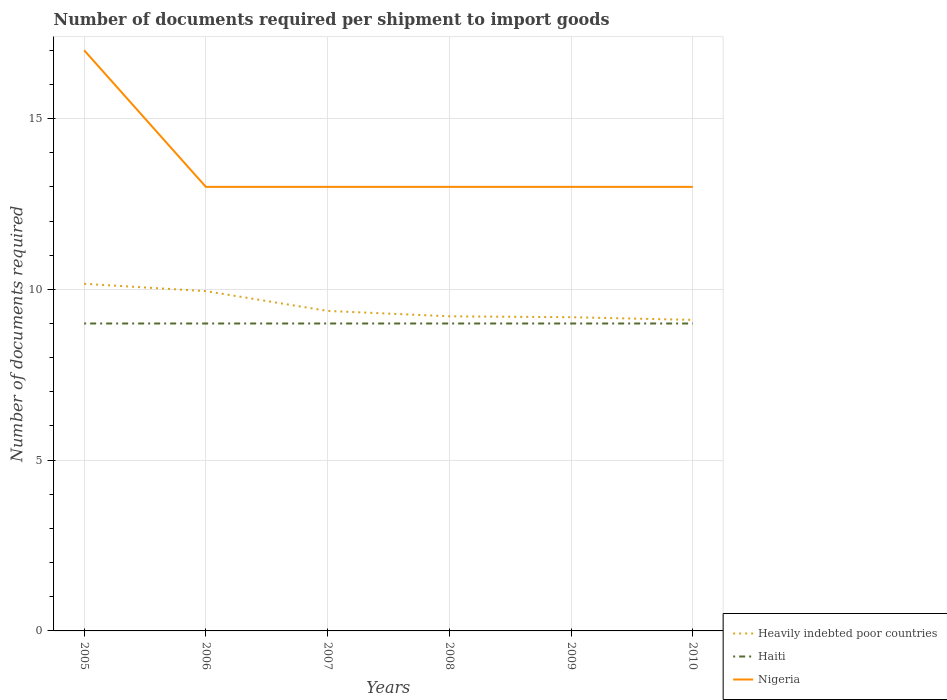Across all years, what is the maximum number of documents required per shipment to import goods in Haiti?
Keep it short and to the point. 9. In which year was the number of documents required per shipment to import goods in Nigeria maximum?
Your response must be concise. 2006. What is the total number of documents required per shipment to import goods in Heavily indebted poor countries in the graph?
Provide a succinct answer. 0.18. What is the difference between the highest and the second highest number of documents required per shipment to import goods in Nigeria?
Offer a terse response. 4. Is the number of documents required per shipment to import goods in Haiti strictly greater than the number of documents required per shipment to import goods in Nigeria over the years?
Keep it short and to the point. Yes. What is the difference between two consecutive major ticks on the Y-axis?
Make the answer very short. 5. How many legend labels are there?
Ensure brevity in your answer.  3. What is the title of the graph?
Your answer should be compact. Number of documents required per shipment to import goods. Does "Monaco" appear as one of the legend labels in the graph?
Give a very brief answer. No. What is the label or title of the Y-axis?
Offer a very short reply. Number of documents required. What is the Number of documents required in Heavily indebted poor countries in 2005?
Make the answer very short. 10.16. What is the Number of documents required in Haiti in 2005?
Make the answer very short. 9. What is the Number of documents required in Heavily indebted poor countries in 2006?
Ensure brevity in your answer.  9.95. What is the Number of documents required of Haiti in 2006?
Provide a short and direct response. 9. What is the Number of documents required in Heavily indebted poor countries in 2007?
Provide a short and direct response. 9.37. What is the Number of documents required of Haiti in 2007?
Your answer should be compact. 9. What is the Number of documents required of Nigeria in 2007?
Your answer should be compact. 13. What is the Number of documents required in Heavily indebted poor countries in 2008?
Your answer should be very brief. 9.21. What is the Number of documents required of Heavily indebted poor countries in 2009?
Provide a short and direct response. 9.18. What is the Number of documents required in Nigeria in 2009?
Provide a short and direct response. 13. What is the Number of documents required of Heavily indebted poor countries in 2010?
Give a very brief answer. 9.11. What is the Number of documents required in Haiti in 2010?
Offer a terse response. 9. What is the Number of documents required in Nigeria in 2010?
Provide a succinct answer. 13. Across all years, what is the maximum Number of documents required in Heavily indebted poor countries?
Offer a very short reply. 10.16. Across all years, what is the minimum Number of documents required in Heavily indebted poor countries?
Your answer should be compact. 9.11. Across all years, what is the minimum Number of documents required of Haiti?
Make the answer very short. 9. Across all years, what is the minimum Number of documents required of Nigeria?
Your answer should be very brief. 13. What is the total Number of documents required of Heavily indebted poor countries in the graph?
Your answer should be very brief. 56.98. What is the total Number of documents required in Nigeria in the graph?
Ensure brevity in your answer.  82. What is the difference between the Number of documents required of Heavily indebted poor countries in 2005 and that in 2006?
Your answer should be very brief. 0.21. What is the difference between the Number of documents required of Nigeria in 2005 and that in 2006?
Provide a succinct answer. 4. What is the difference between the Number of documents required of Heavily indebted poor countries in 2005 and that in 2007?
Make the answer very short. 0.79. What is the difference between the Number of documents required of Haiti in 2005 and that in 2007?
Offer a very short reply. 0. What is the difference between the Number of documents required in Nigeria in 2005 and that in 2007?
Your answer should be very brief. 4. What is the difference between the Number of documents required in Heavily indebted poor countries in 2005 and that in 2008?
Your response must be concise. 0.95. What is the difference between the Number of documents required in Nigeria in 2005 and that in 2008?
Provide a succinct answer. 4. What is the difference between the Number of documents required in Nigeria in 2005 and that in 2009?
Give a very brief answer. 4. What is the difference between the Number of documents required in Heavily indebted poor countries in 2005 and that in 2010?
Make the answer very short. 1.06. What is the difference between the Number of documents required of Haiti in 2005 and that in 2010?
Your response must be concise. 0. What is the difference between the Number of documents required of Heavily indebted poor countries in 2006 and that in 2007?
Offer a terse response. 0.58. What is the difference between the Number of documents required in Heavily indebted poor countries in 2006 and that in 2008?
Keep it short and to the point. 0.74. What is the difference between the Number of documents required of Haiti in 2006 and that in 2008?
Offer a terse response. 0. What is the difference between the Number of documents required in Heavily indebted poor countries in 2006 and that in 2009?
Your answer should be very brief. 0.76. What is the difference between the Number of documents required in Haiti in 2006 and that in 2009?
Provide a succinct answer. 0. What is the difference between the Number of documents required in Heavily indebted poor countries in 2006 and that in 2010?
Give a very brief answer. 0.84. What is the difference between the Number of documents required of Haiti in 2006 and that in 2010?
Offer a very short reply. 0. What is the difference between the Number of documents required of Heavily indebted poor countries in 2007 and that in 2008?
Make the answer very short. 0.16. What is the difference between the Number of documents required of Haiti in 2007 and that in 2008?
Keep it short and to the point. 0. What is the difference between the Number of documents required in Nigeria in 2007 and that in 2008?
Offer a terse response. 0. What is the difference between the Number of documents required in Heavily indebted poor countries in 2007 and that in 2009?
Give a very brief answer. 0.18. What is the difference between the Number of documents required of Haiti in 2007 and that in 2009?
Offer a terse response. 0. What is the difference between the Number of documents required in Nigeria in 2007 and that in 2009?
Offer a very short reply. 0. What is the difference between the Number of documents required of Heavily indebted poor countries in 2007 and that in 2010?
Your answer should be compact. 0.26. What is the difference between the Number of documents required in Nigeria in 2007 and that in 2010?
Provide a short and direct response. 0. What is the difference between the Number of documents required in Heavily indebted poor countries in 2008 and that in 2009?
Make the answer very short. 0.03. What is the difference between the Number of documents required of Haiti in 2008 and that in 2009?
Make the answer very short. 0. What is the difference between the Number of documents required in Nigeria in 2008 and that in 2009?
Your answer should be very brief. 0. What is the difference between the Number of documents required in Heavily indebted poor countries in 2008 and that in 2010?
Make the answer very short. 0.11. What is the difference between the Number of documents required in Heavily indebted poor countries in 2009 and that in 2010?
Offer a very short reply. 0.08. What is the difference between the Number of documents required of Heavily indebted poor countries in 2005 and the Number of documents required of Haiti in 2006?
Provide a succinct answer. 1.16. What is the difference between the Number of documents required in Heavily indebted poor countries in 2005 and the Number of documents required in Nigeria in 2006?
Your answer should be compact. -2.84. What is the difference between the Number of documents required in Heavily indebted poor countries in 2005 and the Number of documents required in Haiti in 2007?
Provide a short and direct response. 1.16. What is the difference between the Number of documents required of Heavily indebted poor countries in 2005 and the Number of documents required of Nigeria in 2007?
Make the answer very short. -2.84. What is the difference between the Number of documents required of Heavily indebted poor countries in 2005 and the Number of documents required of Haiti in 2008?
Provide a short and direct response. 1.16. What is the difference between the Number of documents required of Heavily indebted poor countries in 2005 and the Number of documents required of Nigeria in 2008?
Your answer should be very brief. -2.84. What is the difference between the Number of documents required in Heavily indebted poor countries in 2005 and the Number of documents required in Haiti in 2009?
Your response must be concise. 1.16. What is the difference between the Number of documents required in Heavily indebted poor countries in 2005 and the Number of documents required in Nigeria in 2009?
Keep it short and to the point. -2.84. What is the difference between the Number of documents required of Haiti in 2005 and the Number of documents required of Nigeria in 2009?
Provide a short and direct response. -4. What is the difference between the Number of documents required of Heavily indebted poor countries in 2005 and the Number of documents required of Haiti in 2010?
Give a very brief answer. 1.16. What is the difference between the Number of documents required of Heavily indebted poor countries in 2005 and the Number of documents required of Nigeria in 2010?
Offer a very short reply. -2.84. What is the difference between the Number of documents required in Haiti in 2005 and the Number of documents required in Nigeria in 2010?
Offer a terse response. -4. What is the difference between the Number of documents required in Heavily indebted poor countries in 2006 and the Number of documents required in Nigeria in 2007?
Your answer should be compact. -3.05. What is the difference between the Number of documents required in Haiti in 2006 and the Number of documents required in Nigeria in 2007?
Provide a short and direct response. -4. What is the difference between the Number of documents required of Heavily indebted poor countries in 2006 and the Number of documents required of Haiti in 2008?
Your answer should be very brief. 0.95. What is the difference between the Number of documents required of Heavily indebted poor countries in 2006 and the Number of documents required of Nigeria in 2008?
Your response must be concise. -3.05. What is the difference between the Number of documents required in Haiti in 2006 and the Number of documents required in Nigeria in 2008?
Offer a very short reply. -4. What is the difference between the Number of documents required of Heavily indebted poor countries in 2006 and the Number of documents required of Nigeria in 2009?
Your answer should be very brief. -3.05. What is the difference between the Number of documents required in Haiti in 2006 and the Number of documents required in Nigeria in 2009?
Offer a terse response. -4. What is the difference between the Number of documents required of Heavily indebted poor countries in 2006 and the Number of documents required of Nigeria in 2010?
Your response must be concise. -3.05. What is the difference between the Number of documents required of Haiti in 2006 and the Number of documents required of Nigeria in 2010?
Provide a short and direct response. -4. What is the difference between the Number of documents required in Heavily indebted poor countries in 2007 and the Number of documents required in Haiti in 2008?
Provide a succinct answer. 0.37. What is the difference between the Number of documents required in Heavily indebted poor countries in 2007 and the Number of documents required in Nigeria in 2008?
Your answer should be compact. -3.63. What is the difference between the Number of documents required in Heavily indebted poor countries in 2007 and the Number of documents required in Haiti in 2009?
Offer a very short reply. 0.37. What is the difference between the Number of documents required in Heavily indebted poor countries in 2007 and the Number of documents required in Nigeria in 2009?
Make the answer very short. -3.63. What is the difference between the Number of documents required in Heavily indebted poor countries in 2007 and the Number of documents required in Haiti in 2010?
Offer a terse response. 0.37. What is the difference between the Number of documents required of Heavily indebted poor countries in 2007 and the Number of documents required of Nigeria in 2010?
Make the answer very short. -3.63. What is the difference between the Number of documents required in Haiti in 2007 and the Number of documents required in Nigeria in 2010?
Your answer should be compact. -4. What is the difference between the Number of documents required in Heavily indebted poor countries in 2008 and the Number of documents required in Haiti in 2009?
Provide a succinct answer. 0.21. What is the difference between the Number of documents required in Heavily indebted poor countries in 2008 and the Number of documents required in Nigeria in 2009?
Your answer should be compact. -3.79. What is the difference between the Number of documents required in Haiti in 2008 and the Number of documents required in Nigeria in 2009?
Offer a very short reply. -4. What is the difference between the Number of documents required in Heavily indebted poor countries in 2008 and the Number of documents required in Haiti in 2010?
Offer a terse response. 0.21. What is the difference between the Number of documents required in Heavily indebted poor countries in 2008 and the Number of documents required in Nigeria in 2010?
Your answer should be compact. -3.79. What is the difference between the Number of documents required in Heavily indebted poor countries in 2009 and the Number of documents required in Haiti in 2010?
Make the answer very short. 0.18. What is the difference between the Number of documents required of Heavily indebted poor countries in 2009 and the Number of documents required of Nigeria in 2010?
Your answer should be compact. -3.82. What is the difference between the Number of documents required in Haiti in 2009 and the Number of documents required in Nigeria in 2010?
Offer a very short reply. -4. What is the average Number of documents required of Heavily indebted poor countries per year?
Your answer should be compact. 9.5. What is the average Number of documents required of Nigeria per year?
Offer a terse response. 13.67. In the year 2005, what is the difference between the Number of documents required in Heavily indebted poor countries and Number of documents required in Haiti?
Your response must be concise. 1.16. In the year 2005, what is the difference between the Number of documents required of Heavily indebted poor countries and Number of documents required of Nigeria?
Make the answer very short. -6.84. In the year 2005, what is the difference between the Number of documents required in Haiti and Number of documents required in Nigeria?
Your answer should be compact. -8. In the year 2006, what is the difference between the Number of documents required of Heavily indebted poor countries and Number of documents required of Nigeria?
Offer a very short reply. -3.05. In the year 2007, what is the difference between the Number of documents required of Heavily indebted poor countries and Number of documents required of Haiti?
Ensure brevity in your answer.  0.37. In the year 2007, what is the difference between the Number of documents required of Heavily indebted poor countries and Number of documents required of Nigeria?
Offer a very short reply. -3.63. In the year 2007, what is the difference between the Number of documents required of Haiti and Number of documents required of Nigeria?
Your answer should be very brief. -4. In the year 2008, what is the difference between the Number of documents required of Heavily indebted poor countries and Number of documents required of Haiti?
Provide a succinct answer. 0.21. In the year 2008, what is the difference between the Number of documents required in Heavily indebted poor countries and Number of documents required in Nigeria?
Provide a succinct answer. -3.79. In the year 2008, what is the difference between the Number of documents required in Haiti and Number of documents required in Nigeria?
Provide a short and direct response. -4. In the year 2009, what is the difference between the Number of documents required in Heavily indebted poor countries and Number of documents required in Haiti?
Make the answer very short. 0.18. In the year 2009, what is the difference between the Number of documents required of Heavily indebted poor countries and Number of documents required of Nigeria?
Ensure brevity in your answer.  -3.82. In the year 2010, what is the difference between the Number of documents required of Heavily indebted poor countries and Number of documents required of Haiti?
Provide a short and direct response. 0.11. In the year 2010, what is the difference between the Number of documents required of Heavily indebted poor countries and Number of documents required of Nigeria?
Provide a succinct answer. -3.89. In the year 2010, what is the difference between the Number of documents required in Haiti and Number of documents required in Nigeria?
Provide a succinct answer. -4. What is the ratio of the Number of documents required in Heavily indebted poor countries in 2005 to that in 2006?
Provide a succinct answer. 1.02. What is the ratio of the Number of documents required in Haiti in 2005 to that in 2006?
Offer a terse response. 1. What is the ratio of the Number of documents required in Nigeria in 2005 to that in 2006?
Offer a very short reply. 1.31. What is the ratio of the Number of documents required in Heavily indebted poor countries in 2005 to that in 2007?
Provide a succinct answer. 1.08. What is the ratio of the Number of documents required of Nigeria in 2005 to that in 2007?
Provide a succinct answer. 1.31. What is the ratio of the Number of documents required in Heavily indebted poor countries in 2005 to that in 2008?
Your response must be concise. 1.1. What is the ratio of the Number of documents required in Nigeria in 2005 to that in 2008?
Offer a very short reply. 1.31. What is the ratio of the Number of documents required in Heavily indebted poor countries in 2005 to that in 2009?
Provide a short and direct response. 1.11. What is the ratio of the Number of documents required in Nigeria in 2005 to that in 2009?
Your answer should be compact. 1.31. What is the ratio of the Number of documents required in Heavily indebted poor countries in 2005 to that in 2010?
Your answer should be very brief. 1.12. What is the ratio of the Number of documents required of Haiti in 2005 to that in 2010?
Ensure brevity in your answer.  1. What is the ratio of the Number of documents required in Nigeria in 2005 to that in 2010?
Ensure brevity in your answer.  1.31. What is the ratio of the Number of documents required of Heavily indebted poor countries in 2006 to that in 2007?
Your answer should be very brief. 1.06. What is the ratio of the Number of documents required of Haiti in 2006 to that in 2007?
Ensure brevity in your answer.  1. What is the ratio of the Number of documents required in Heavily indebted poor countries in 2006 to that in 2008?
Your answer should be compact. 1.08. What is the ratio of the Number of documents required in Haiti in 2006 to that in 2008?
Give a very brief answer. 1. What is the ratio of the Number of documents required in Nigeria in 2006 to that in 2008?
Provide a succinct answer. 1. What is the ratio of the Number of documents required of Heavily indebted poor countries in 2006 to that in 2009?
Make the answer very short. 1.08. What is the ratio of the Number of documents required of Haiti in 2006 to that in 2009?
Give a very brief answer. 1. What is the ratio of the Number of documents required of Heavily indebted poor countries in 2006 to that in 2010?
Your answer should be compact. 1.09. What is the ratio of the Number of documents required in Haiti in 2006 to that in 2010?
Your answer should be very brief. 1. What is the ratio of the Number of documents required in Nigeria in 2006 to that in 2010?
Offer a terse response. 1. What is the ratio of the Number of documents required of Heavily indebted poor countries in 2007 to that in 2008?
Provide a succinct answer. 1.02. What is the ratio of the Number of documents required in Haiti in 2007 to that in 2008?
Offer a terse response. 1. What is the ratio of the Number of documents required of Nigeria in 2007 to that in 2008?
Your answer should be compact. 1. What is the ratio of the Number of documents required of Heavily indebted poor countries in 2007 to that in 2009?
Make the answer very short. 1.02. What is the ratio of the Number of documents required in Nigeria in 2007 to that in 2009?
Provide a short and direct response. 1. What is the ratio of the Number of documents required in Heavily indebted poor countries in 2007 to that in 2010?
Make the answer very short. 1.03. What is the ratio of the Number of documents required of Haiti in 2007 to that in 2010?
Keep it short and to the point. 1. What is the ratio of the Number of documents required in Heavily indebted poor countries in 2008 to that in 2009?
Make the answer very short. 1. What is the ratio of the Number of documents required of Haiti in 2008 to that in 2009?
Ensure brevity in your answer.  1. What is the ratio of the Number of documents required in Heavily indebted poor countries in 2008 to that in 2010?
Your answer should be very brief. 1.01. What is the ratio of the Number of documents required in Haiti in 2008 to that in 2010?
Offer a terse response. 1. What is the ratio of the Number of documents required in Heavily indebted poor countries in 2009 to that in 2010?
Give a very brief answer. 1.01. What is the ratio of the Number of documents required in Haiti in 2009 to that in 2010?
Provide a succinct answer. 1. What is the ratio of the Number of documents required of Nigeria in 2009 to that in 2010?
Provide a succinct answer. 1. What is the difference between the highest and the second highest Number of documents required of Heavily indebted poor countries?
Your response must be concise. 0.21. What is the difference between the highest and the second highest Number of documents required in Haiti?
Your answer should be compact. 0. What is the difference between the highest and the lowest Number of documents required in Heavily indebted poor countries?
Your answer should be very brief. 1.06. 